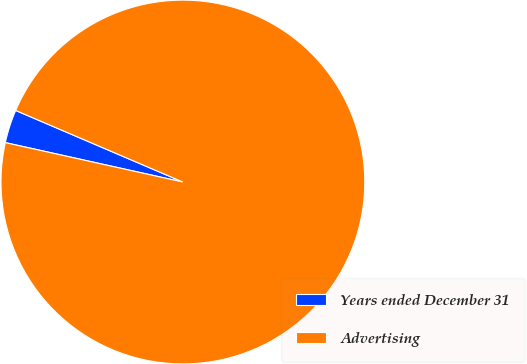Convert chart. <chart><loc_0><loc_0><loc_500><loc_500><pie_chart><fcel>Years ended December 31<fcel>Advertising<nl><fcel>2.96%<fcel>97.04%<nl></chart> 